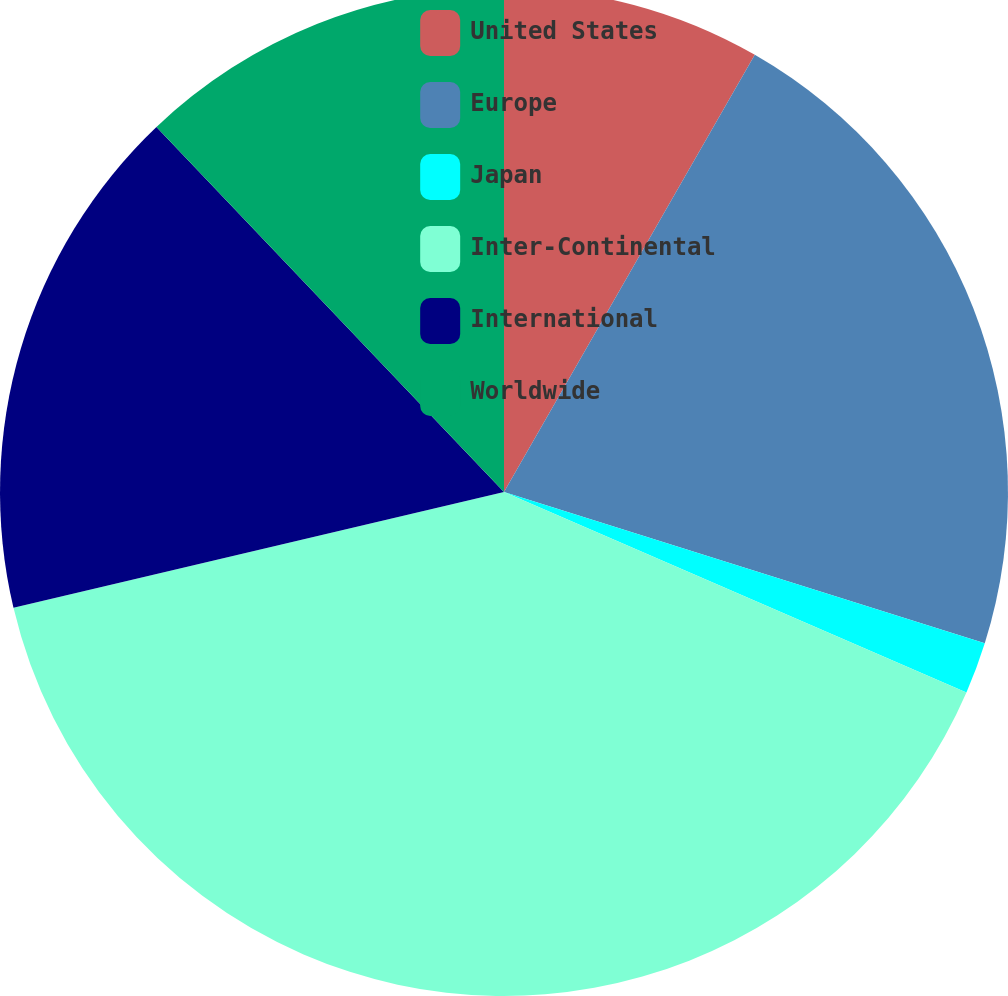<chart> <loc_0><loc_0><loc_500><loc_500><pie_chart><fcel>United States<fcel>Europe<fcel>Japan<fcel>Inter-Continental<fcel>International<fcel>Worldwide<nl><fcel>8.29%<fcel>21.56%<fcel>1.66%<fcel>39.8%<fcel>16.58%<fcel>12.11%<nl></chart> 